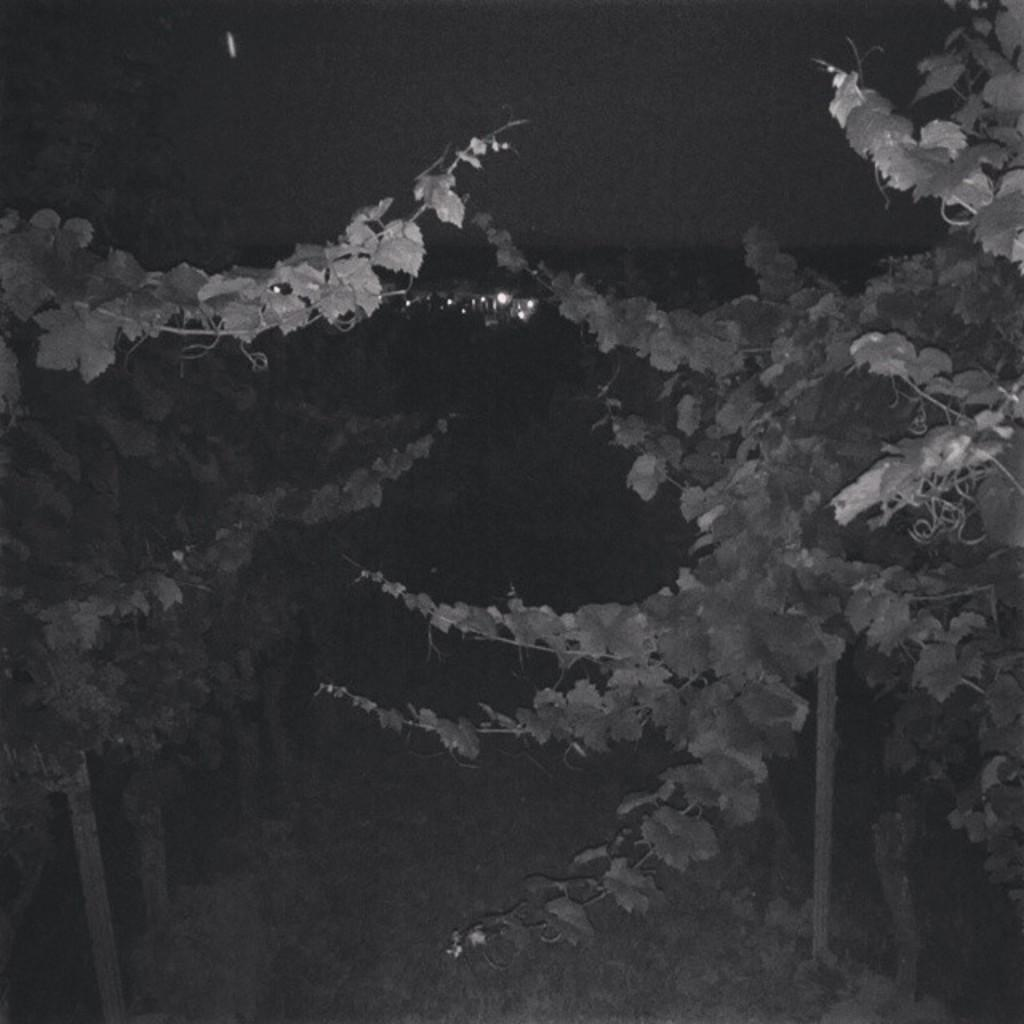What is the overall lighting condition in the image? The image is dark. What type of vegetation can be seen in the image? There are trees in the image. What is covering the ground in the image? There is grass on the ground in the image. What can be seen illuminating the scene in the image? There are lights visible in the image. What is visible in the background of the image? The sky is visible in the background of the image. What type of education is being discussed in the image? There is no discussion of education in the image; it primarily features trees, grass, lights, and a dark setting. What kind of leather material is visible in the image? There is no leather material present in the image. 